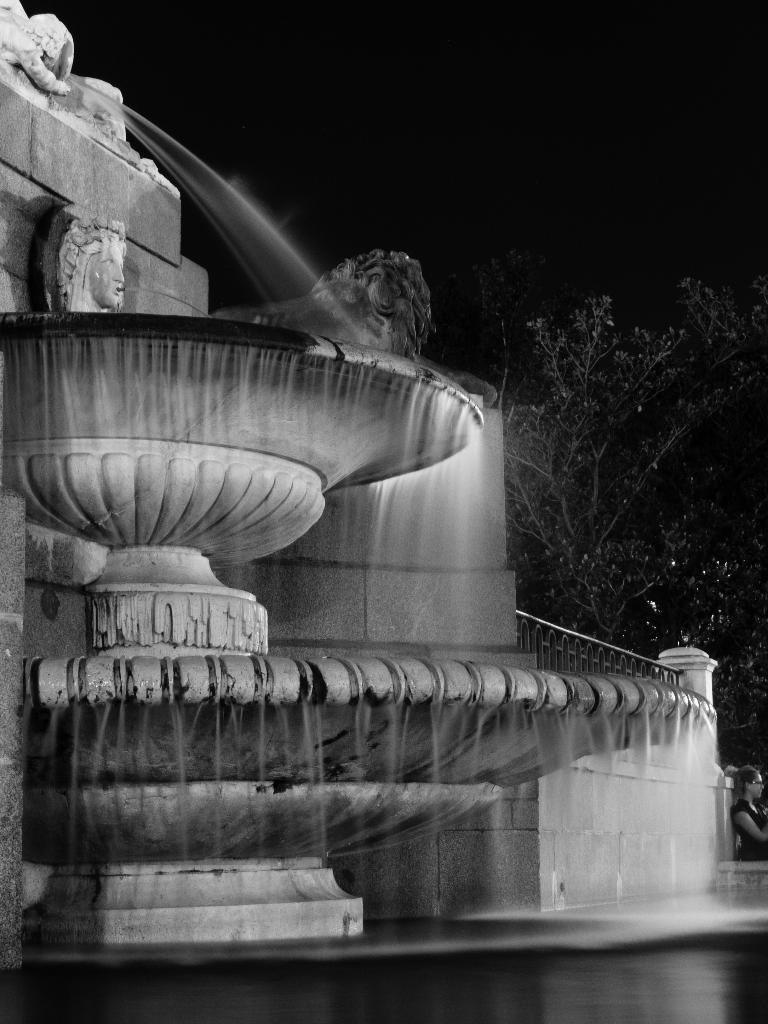What is the main feature in the image? There is a fountain in the image. What is happening with the fountain? Water is falling from the fountain. Are there any other natural elements in the image? Yes, there is a tree in the image. How can you tell that the image is a night view? The image is a night view because it is dark and the fountain and tree are illuminated. Where is the star located in the image? There is no star present in the image. What type of pump is used to operate the fountain in the image? The image does not provide information about the type of pump used to operate the fountain. Can you see any shelves in the image? There are no shelves present in the image. 